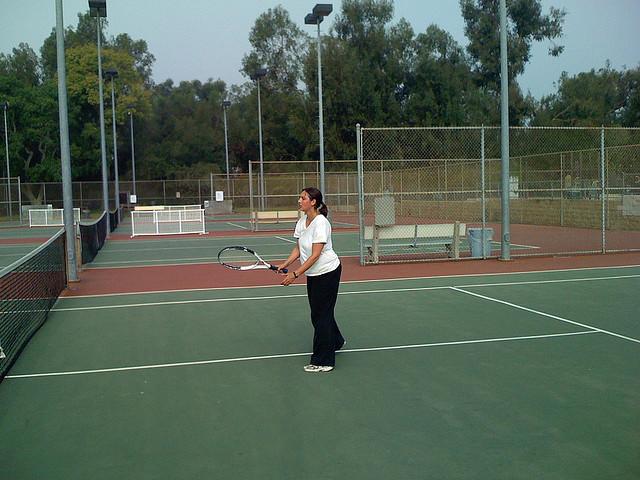Is this a doubles or singles tennis match?
Quick response, please. Singles. What is on the white bench?
Concise answer only. Nothing. Do you think the instructor is pictured?
Quick response, please. No. What color is her tennis racquet?
Write a very short answer. Black and white. What sport is the woman playing?
Be succinct. Tennis. Is the woman wearing shorts?
Quick response, please. No. What is the woman holding?
Concise answer only. Tennis racket. 